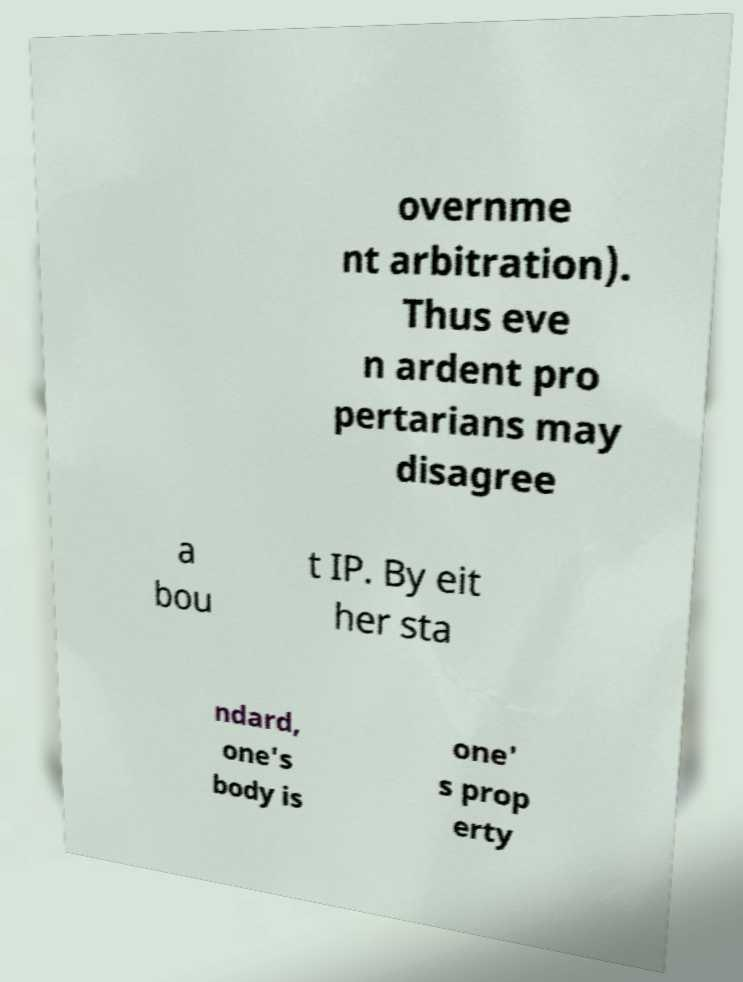Can you accurately transcribe the text from the provided image for me? overnme nt arbitration). Thus eve n ardent pro pertarians may disagree a bou t IP. By eit her sta ndard, one's body is one' s prop erty 